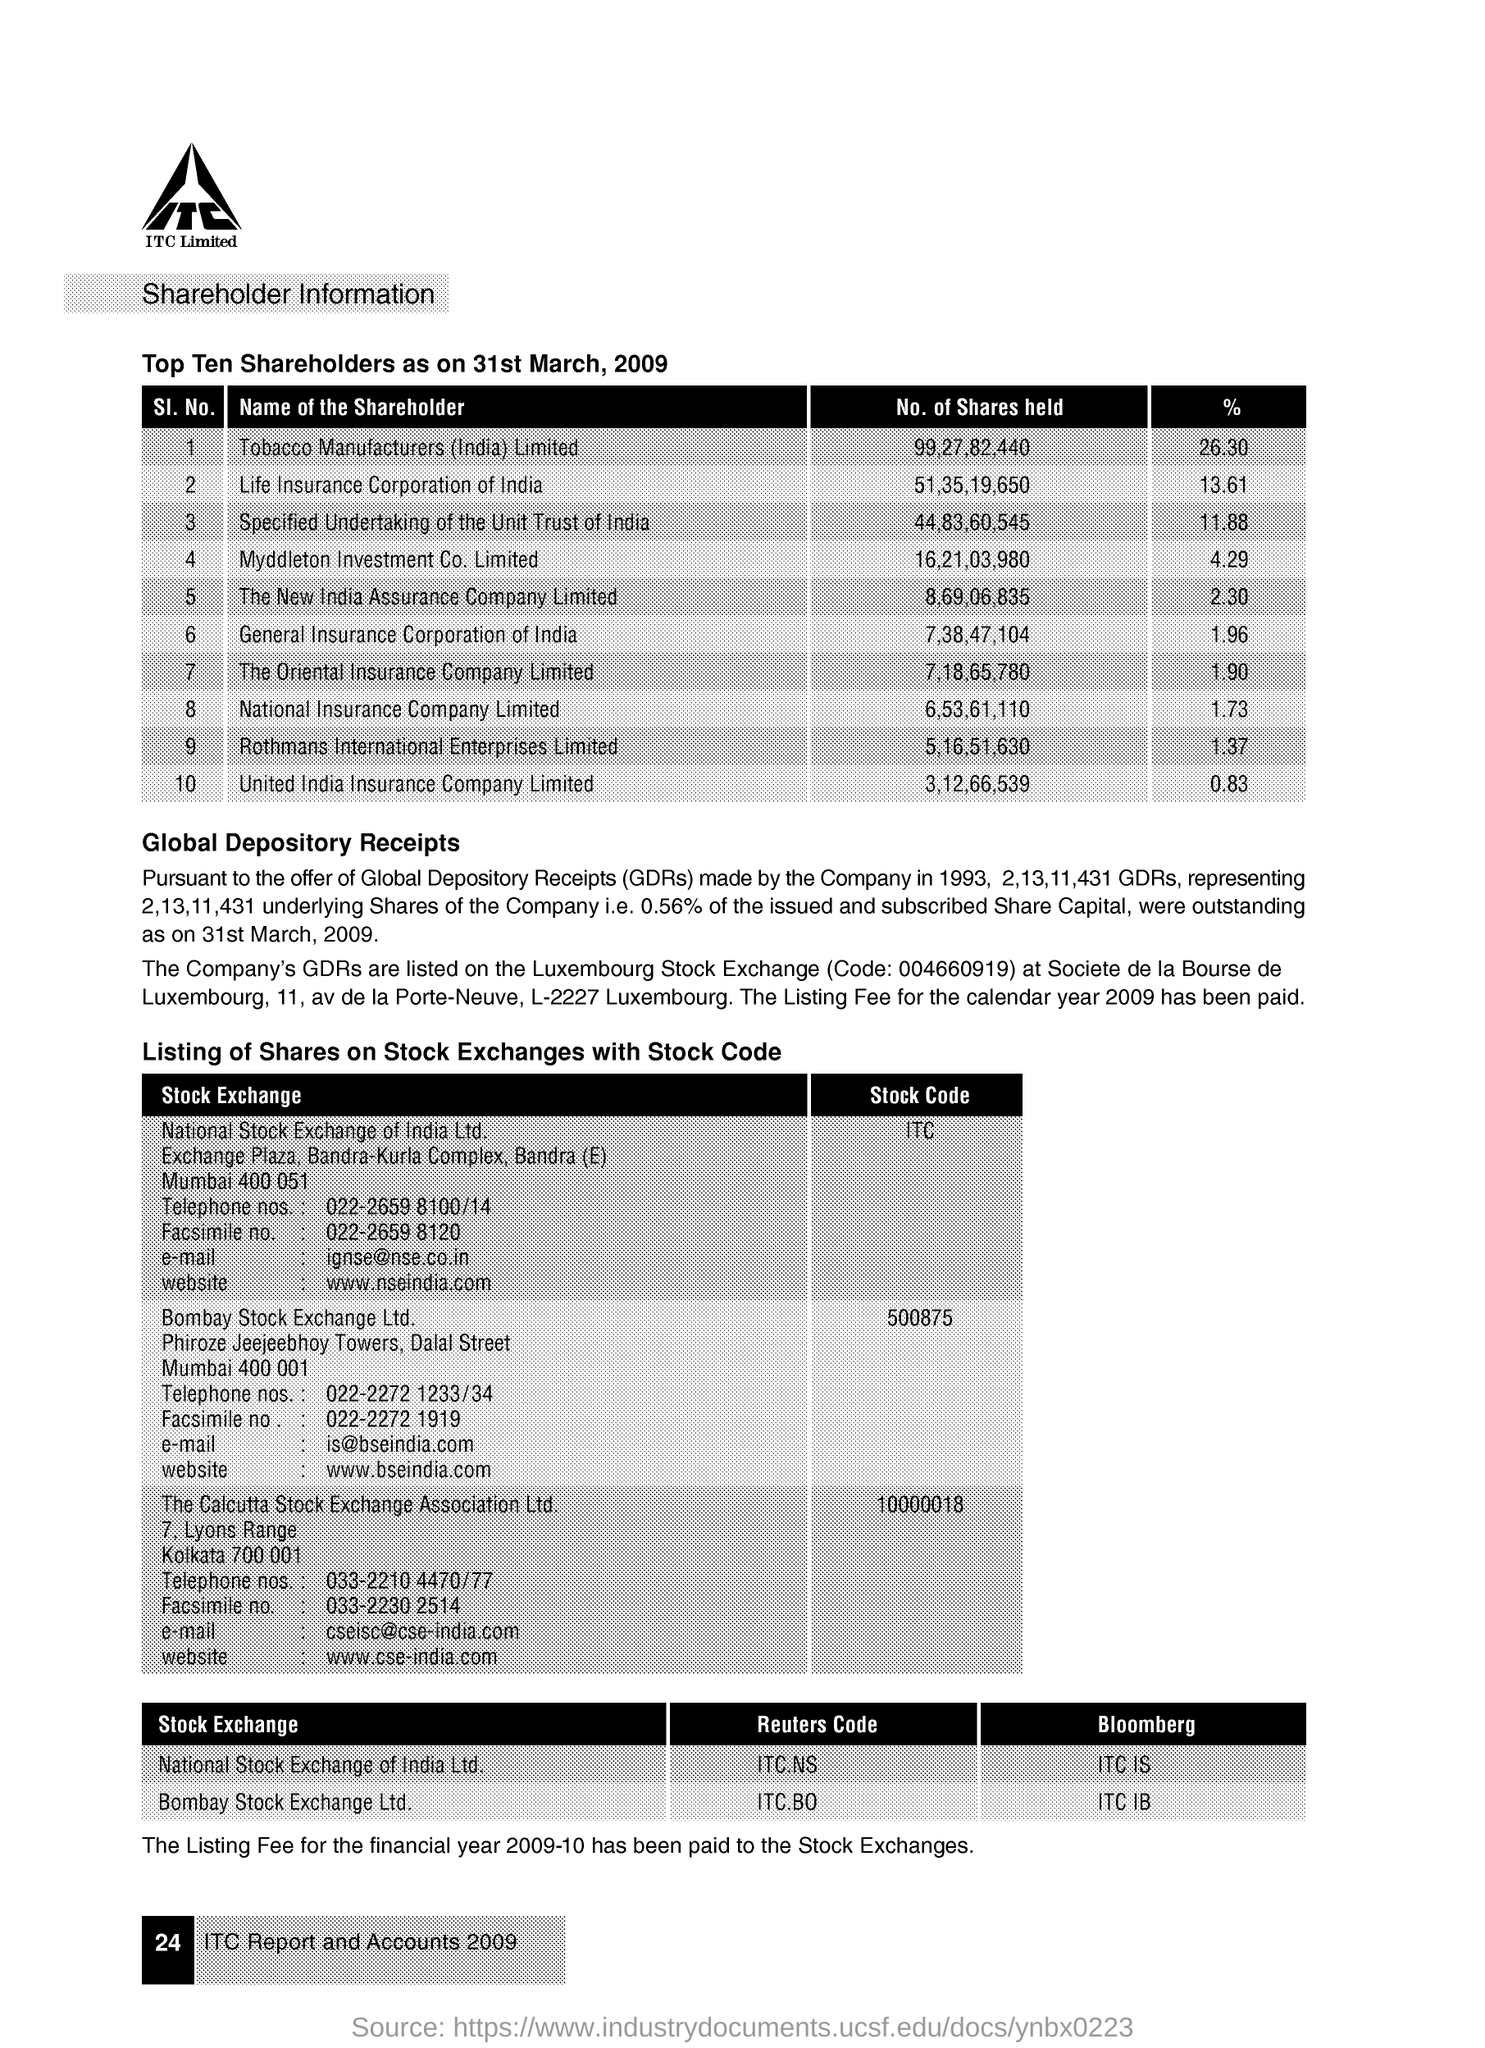What is the stock code of the national stock exchange of india ltd .
Your answer should be compact. ITC. What is the % of tobacco manufactures (india) limited ?
Ensure brevity in your answer.  26.3. What is the stock code of bombay stock exchange ltd
Offer a terse response. 500875. What is the full form of gdr's ?
Give a very brief answer. Global Depository Receipts. 